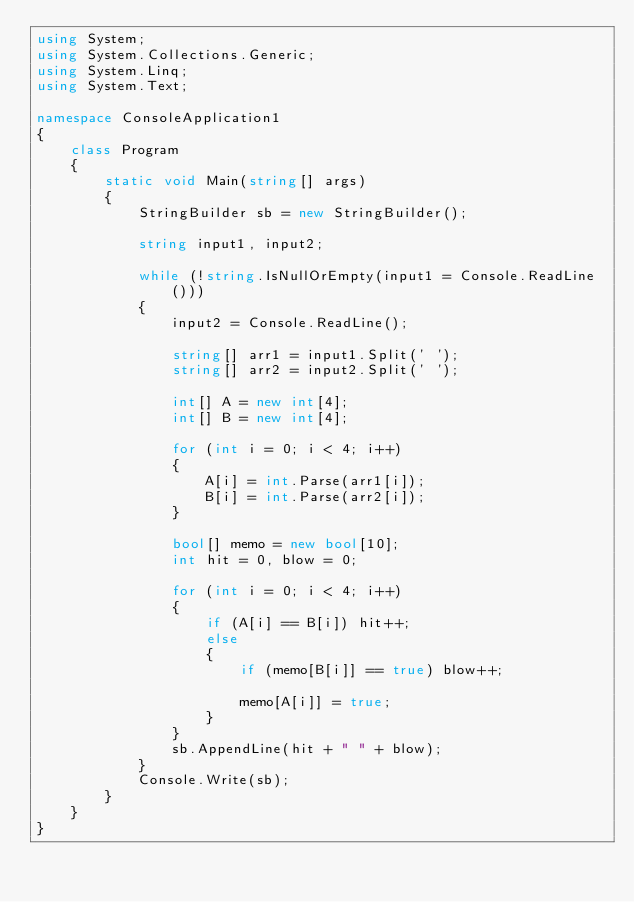Convert code to text. <code><loc_0><loc_0><loc_500><loc_500><_C#_>using System;
using System.Collections.Generic;
using System.Linq;
using System.Text;

namespace ConsoleApplication1
{
    class Program
    {
        static void Main(string[] args)
        {
            StringBuilder sb = new StringBuilder();

            string input1, input2;

            while (!string.IsNullOrEmpty(input1 = Console.ReadLine()))
            {
                input2 = Console.ReadLine();

                string[] arr1 = input1.Split(' ');
                string[] arr2 = input2.Split(' ');

                int[] A = new int[4];
                int[] B = new int[4];

                for (int i = 0; i < 4; i++)
                {
                    A[i] = int.Parse(arr1[i]);
                    B[i] = int.Parse(arr2[i]);
                }

                bool[] memo = new bool[10];
                int hit = 0, blow = 0;

                for (int i = 0; i < 4; i++)
                {
                    if (A[i] == B[i]) hit++;
                    else
                    {
                        if (memo[B[i]] == true) blow++;

                        memo[A[i]] = true;
                    }
                }
                sb.AppendLine(hit + " " + blow);
            }
            Console.Write(sb);
        }
    }
}</code> 